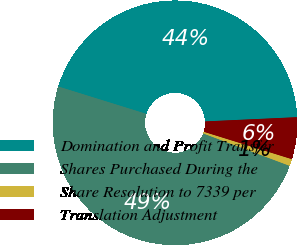Convert chart to OTSL. <chart><loc_0><loc_0><loc_500><loc_500><pie_chart><fcel>Domination and Profit Transfer<fcel>Shares Purchased During the<fcel>Share Resolution to 7339 per<fcel>Translation Adjustment<nl><fcel>44.47%<fcel>49.09%<fcel>0.91%<fcel>5.53%<nl></chart> 